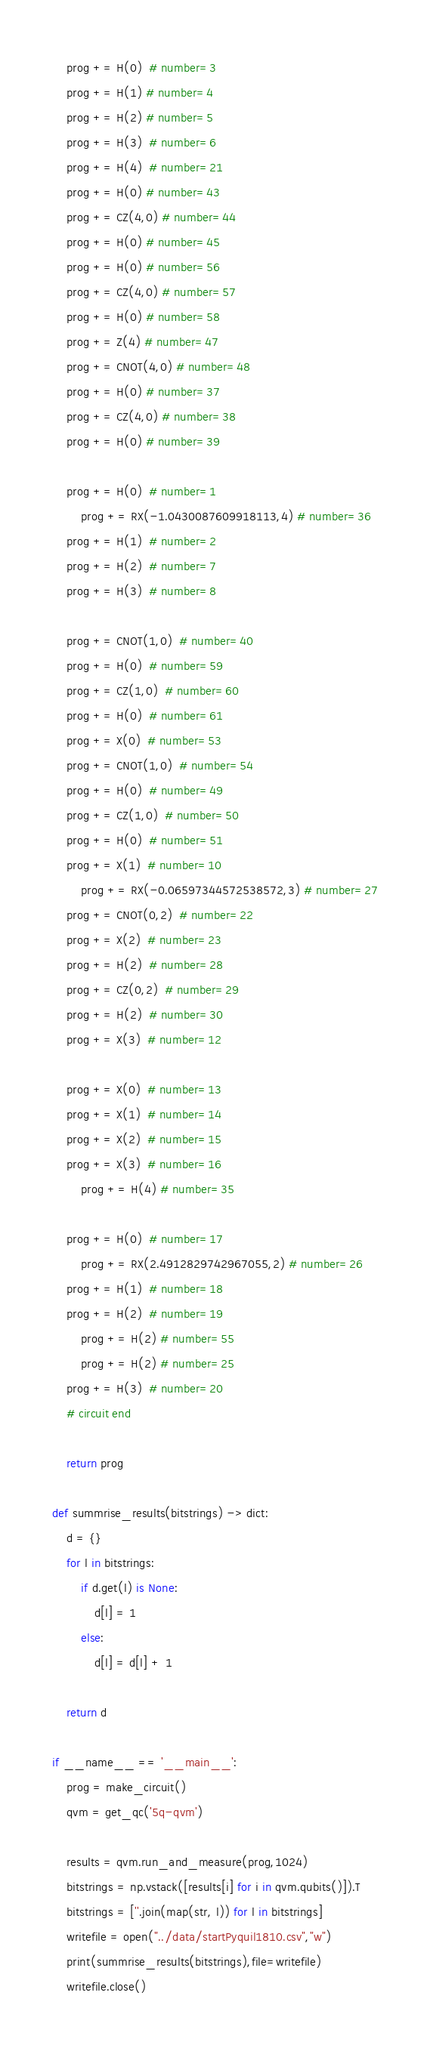<code> <loc_0><loc_0><loc_500><loc_500><_Python_>
    prog += H(0)  # number=3
    prog += H(1) # number=4
    prog += H(2) # number=5
    prog += H(3)  # number=6
    prog += H(4)  # number=21
    prog += H(0) # number=43
    prog += CZ(4,0) # number=44
    prog += H(0) # number=45
    prog += H(0) # number=56
    prog += CZ(4,0) # number=57
    prog += H(0) # number=58
    prog += Z(4) # number=47
    prog += CNOT(4,0) # number=48
    prog += H(0) # number=37
    prog += CZ(4,0) # number=38
    prog += H(0) # number=39

    prog += H(0)  # number=1
        prog += RX(-1.0430087609918113,4) # number=36
    prog += H(1)  # number=2
    prog += H(2)  # number=7
    prog += H(3)  # number=8

    prog += CNOT(1,0)  # number=40
    prog += H(0)  # number=59
    prog += CZ(1,0)  # number=60
    prog += H(0)  # number=61
    prog += X(0)  # number=53
    prog += CNOT(1,0)  # number=54
    prog += H(0)  # number=49
    prog += CZ(1,0)  # number=50
    prog += H(0)  # number=51
    prog += X(1)  # number=10
        prog += RX(-0.06597344572538572,3) # number=27
    prog += CNOT(0,2)  # number=22
    prog += X(2)  # number=23
    prog += H(2)  # number=28
    prog += CZ(0,2)  # number=29
    prog += H(2)  # number=30
    prog += X(3)  # number=12

    prog += X(0)  # number=13
    prog += X(1)  # number=14
    prog += X(2)  # number=15
    prog += X(3)  # number=16
        prog += H(4) # number=35

    prog += H(0)  # number=17
        prog += RX(2.4912829742967055,2) # number=26
    prog += H(1)  # number=18
    prog += H(2)  # number=19
        prog += H(2) # number=55
        prog += H(2) # number=25
    prog += H(3)  # number=20
    # circuit end

    return prog

def summrise_results(bitstrings) -> dict:
    d = {}
    for l in bitstrings:
        if d.get(l) is None:
            d[l] = 1
        else:
            d[l] = d[l] + 1

    return d

if __name__ == '__main__':
    prog = make_circuit()
    qvm = get_qc('5q-qvm')

    results = qvm.run_and_measure(prog,1024)
    bitstrings = np.vstack([results[i] for i in qvm.qubits()]).T
    bitstrings = [''.join(map(str, l)) for l in bitstrings]
    writefile = open("../data/startPyquil1810.csv","w")
    print(summrise_results(bitstrings),file=writefile)
    writefile.close()

</code> 